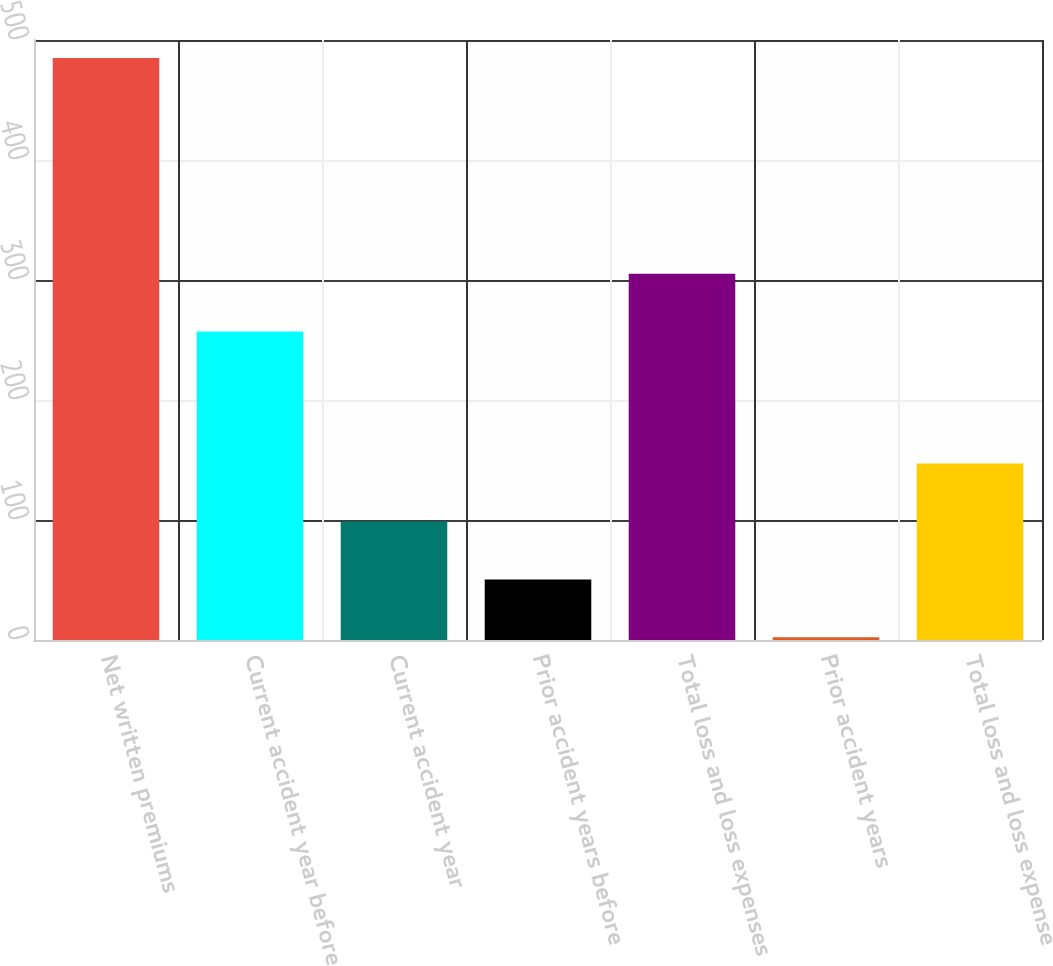Convert chart. <chart><loc_0><loc_0><loc_500><loc_500><bar_chart><fcel>Net written premiums<fcel>Current accident year before<fcel>Current accident year<fcel>Prior accident years before<fcel>Total loss and loss expenses<fcel>Prior accident years<fcel>Total loss and loss expense<nl><fcel>485<fcel>257<fcel>98.76<fcel>50.48<fcel>305.28<fcel>2.2<fcel>147.04<nl></chart> 